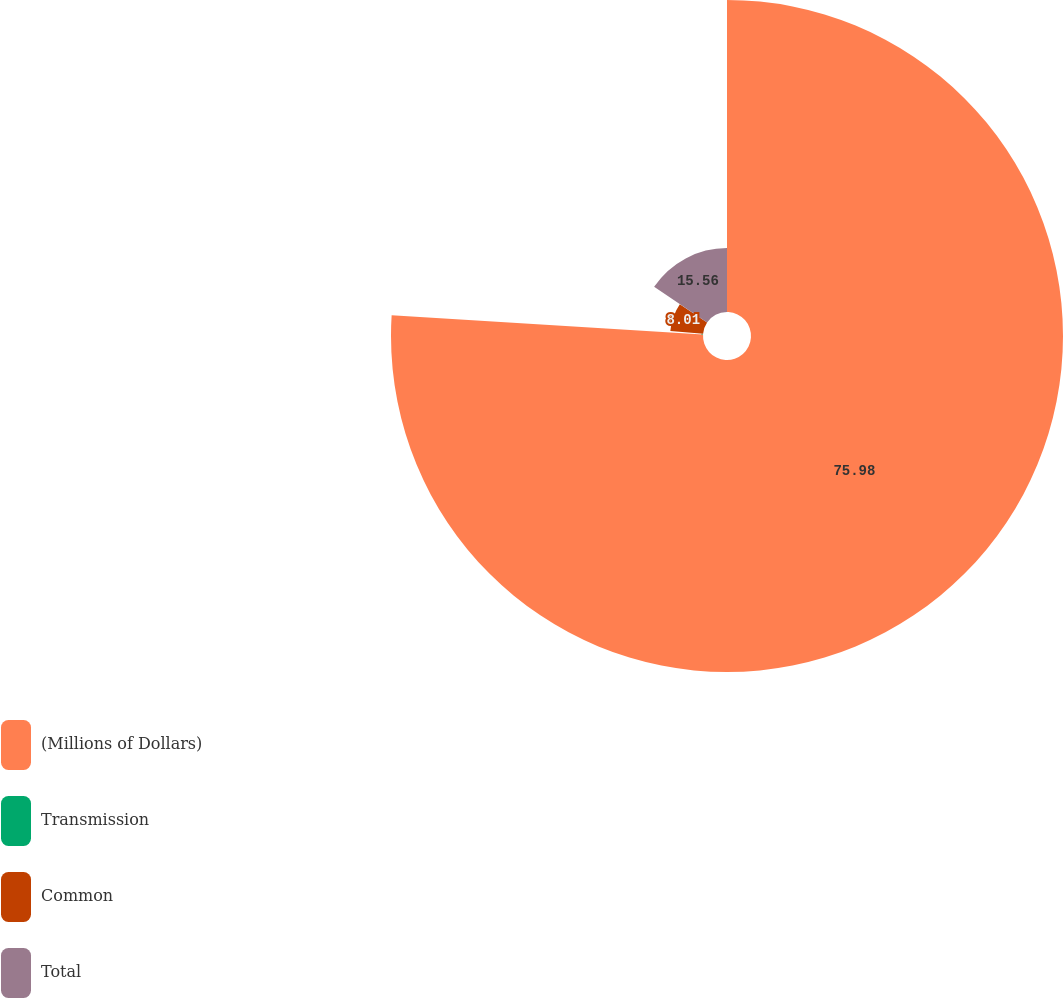Convert chart. <chart><loc_0><loc_0><loc_500><loc_500><pie_chart><fcel>(Millions of Dollars)<fcel>Transmission<fcel>Common<fcel>Total<nl><fcel>75.98%<fcel>0.45%<fcel>8.01%<fcel>15.56%<nl></chart> 